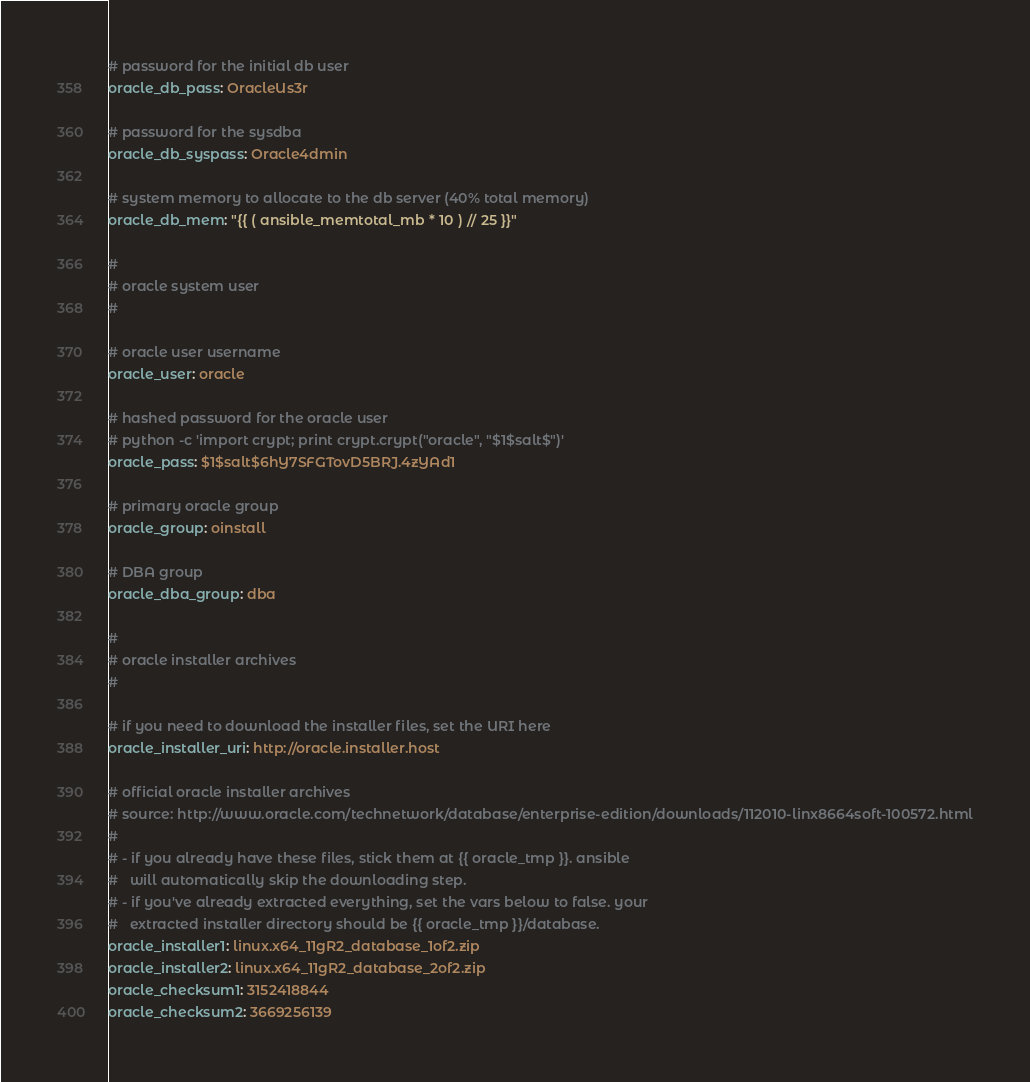<code> <loc_0><loc_0><loc_500><loc_500><_YAML_># password for the initial db user
oracle_db_pass: OracleUs3r

# password for the sysdba
oracle_db_syspass: Oracle4dmin

# system memory to allocate to the db server (40% total memory)
oracle_db_mem: "{{ ( ansible_memtotal_mb * 10 ) // 25 }}"

#
# oracle system user
#

# oracle user username
oracle_user: oracle

# hashed password for the oracle user
# python -c 'import crypt; print crypt.crypt("oracle", "$1$salt$")'
oracle_pass: $1$salt$6hY7SFGTovD5BRJ.4zYAd1

# primary oracle group
oracle_group: oinstall

# DBA group
oracle_dba_group: dba

#
# oracle installer archives
#

# if you need to download the installer files, set the URI here
oracle_installer_uri: http://oracle.installer.host

# official oracle installer archives
# source: http://www.oracle.com/technetwork/database/enterprise-edition/downloads/112010-linx8664soft-100572.html
#
# - if you already have these files, stick them at {{ oracle_tmp }}. ansible
#   will automatically skip the downloading step.
# - if you've already extracted everything, set the vars below to false. your
#   extracted installer directory should be {{ oracle_tmp }}/database.
oracle_installer1: linux.x64_11gR2_database_1of2.zip
oracle_installer2: linux.x64_11gR2_database_2of2.zip
oracle_checksum1: 3152418844
oracle_checksum2: 3669256139
</code> 